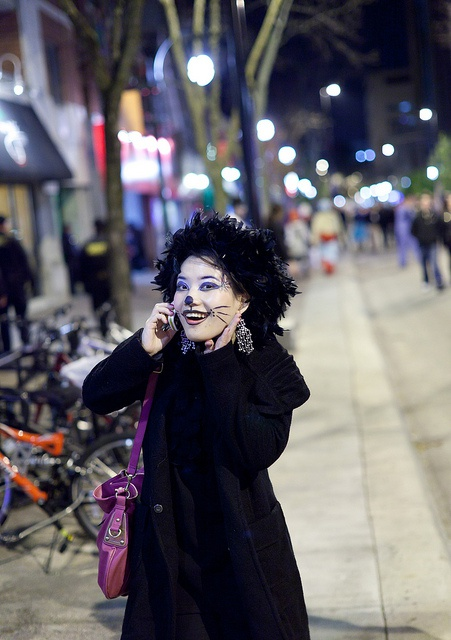Describe the objects in this image and their specific colors. I can see people in gray, black, lightgray, and darkgray tones, bicycle in gray, black, and darkgray tones, bicycle in gray, black, and maroon tones, handbag in gray, purple, and black tones, and people in gray, black, and darkgray tones in this image. 